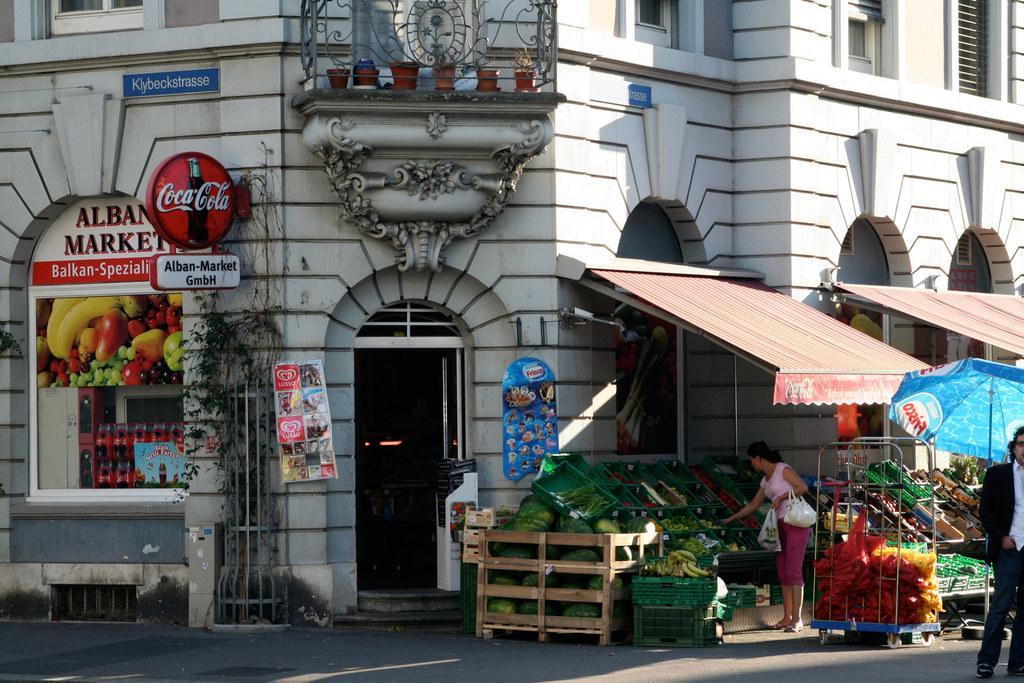Please provide a concise description of this image. In this picture we can see few people and a building, in front of the building we can find fruits and other things in the trays, and also we can see an umbrella, on the left side of the image we can see hoardings and plants, on top of the image we can find few flower pots. 